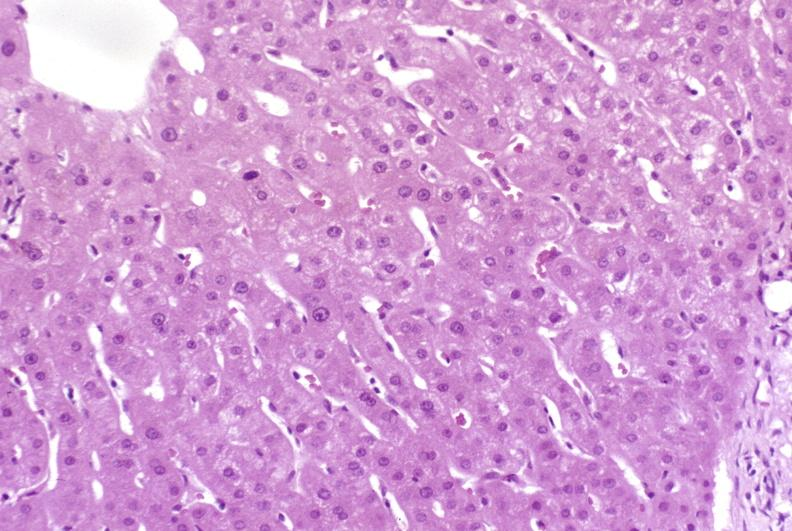s adenoma present?
Answer the question using a single word or phrase. No 